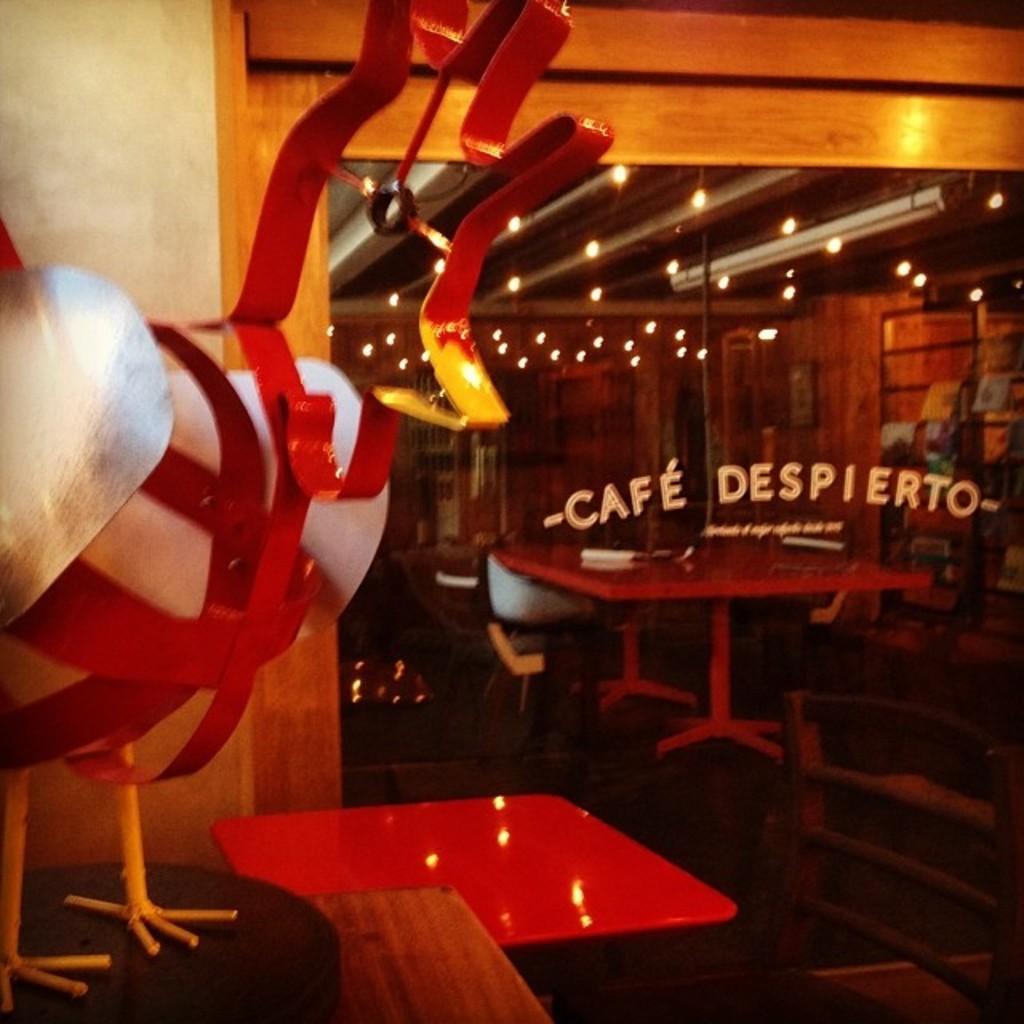Can you describe this image briefly? In the image there is a model of the hen in the foreground, behind the model there are empty tables and there is a cafe name on the doors in front of the tables. 